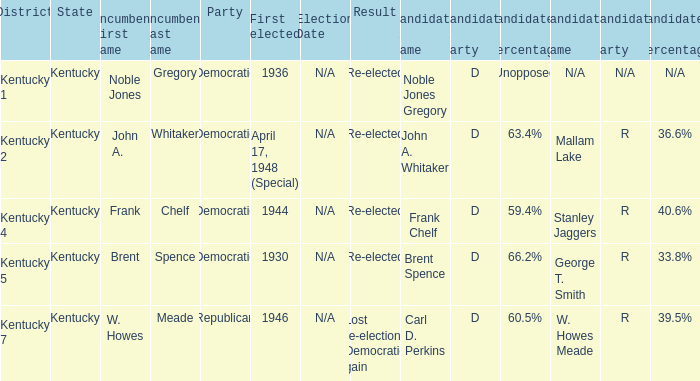What was the result of the election incumbent Brent Spence took place in? Re-elected. 